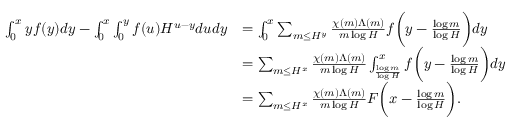Convert formula to latex. <formula><loc_0><loc_0><loc_500><loc_500>\begin{array} { r l } { \int _ { 0 } ^ { x } y f ( y ) d y - \int _ { 0 } ^ { x } \int _ { 0 } ^ { y } f ( u ) H ^ { u - y } d u d y } & { = \int _ { 0 } ^ { x } \sum _ { m \leq H ^ { y } } \frac { \chi ( m ) \Lambda ( m ) } { m \log H } f \left ( y - \frac { \log m } { \log H } \right ) d y } \\ & { = \sum _ { m \leq H ^ { x } } \frac { \chi ( m ) \Lambda ( m ) } { m \log H } \int _ { \frac { \log m } { \log H } } ^ { x } f \left ( y - \frac { \log m } { \log H } \right ) d y } \\ & { = \sum _ { m \leq H ^ { x } } \frac { \chi ( m ) \Lambda ( m ) } { m \log H } F \left ( x - \frac { \log m } { \log H } \right ) . } \end{array}</formula> 